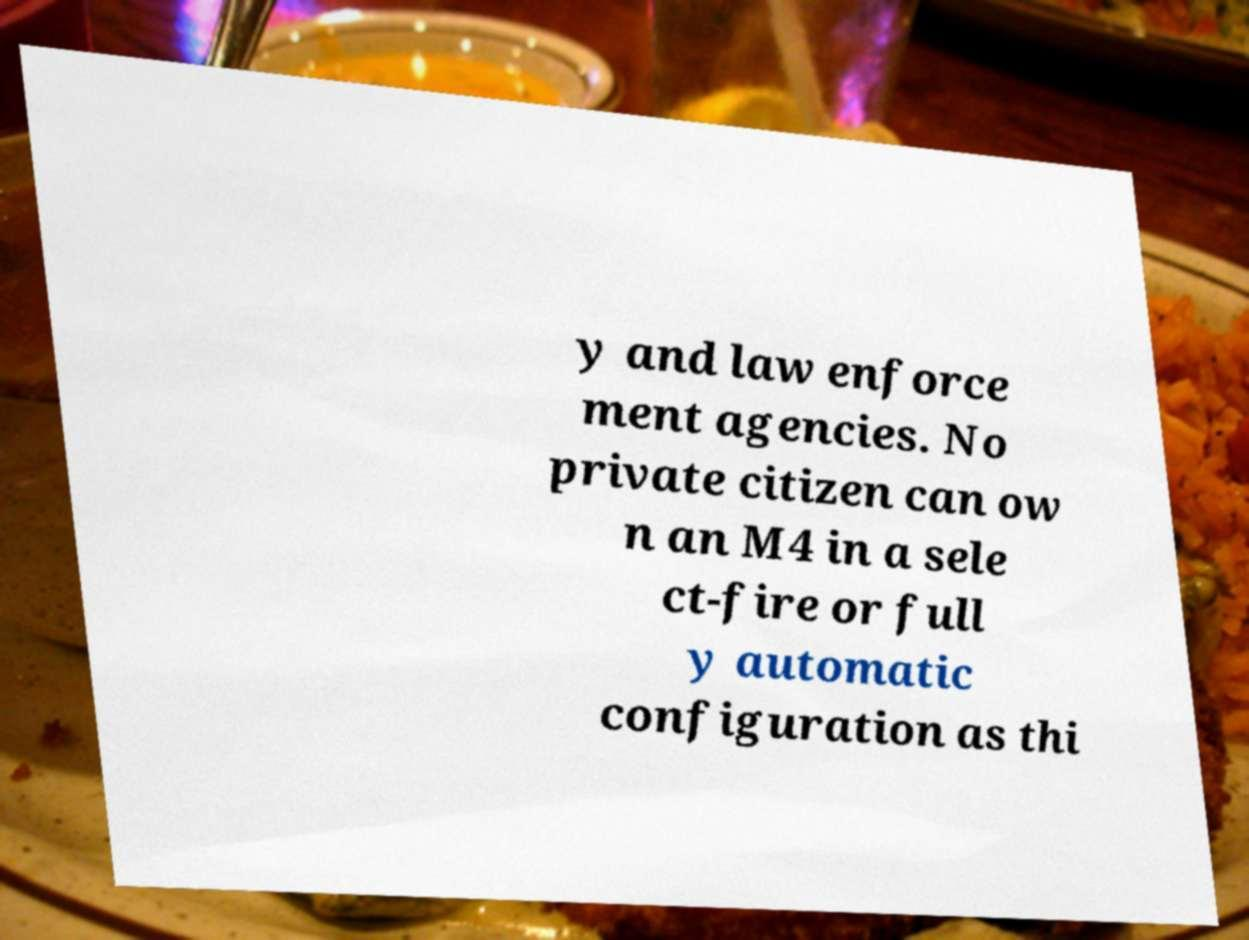Can you read and provide the text displayed in the image?This photo seems to have some interesting text. Can you extract and type it out for me? y and law enforce ment agencies. No private citizen can ow n an M4 in a sele ct-fire or full y automatic configuration as thi 